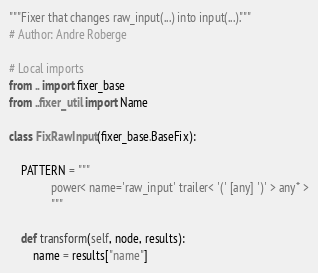Convert code to text. <code><loc_0><loc_0><loc_500><loc_500><_Python_>"""Fixer that changes raw_input(...) into input(...)."""
# Author: Andre Roberge

# Local imports
from .. import fixer_base
from ..fixer_util import Name

class FixRawInput(fixer_base.BaseFix):

    PATTERN = """
              power< name='raw_input' trailer< '(' [any] ')' > any* >
              """

    def transform(self, node, results):
        name = results["name"]</code> 